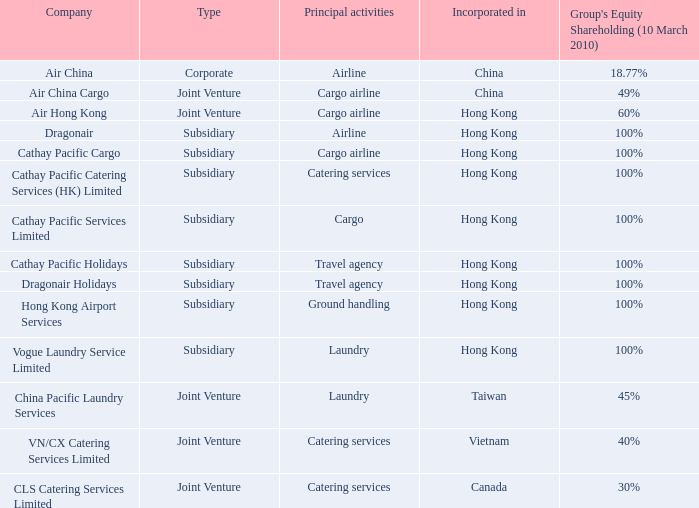Which company's principal activities are catering services, and a Group's Equity Shareholding (as of March 10th 2010) of 40%? VN/CX Catering Services Limited. 